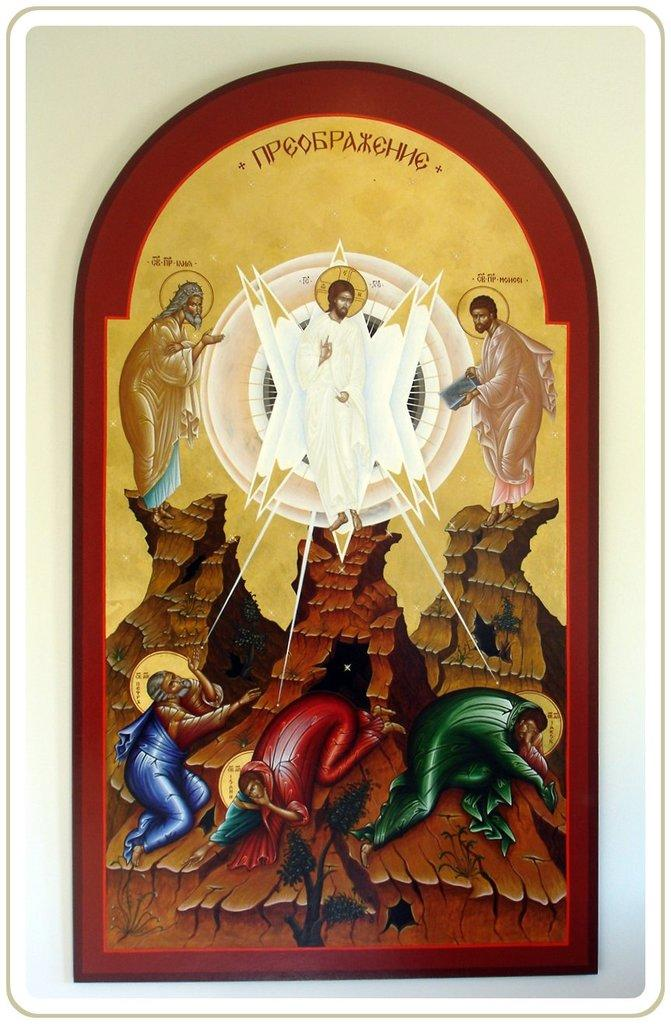What object is present in the image that typically holds a photo? There is a photo frame in the image. What can be seen inside the photo frame? There are persons in the photo frame. Is there any text on the photo frame? Yes, there is text on the photo frame. What is visible in the background of the image? There is a wall in the background of the image. Can you tell me how many toys are scattered around the sheep in the image? There are no toys or sheep present in the image; it only features a photo frame with persons and text. 